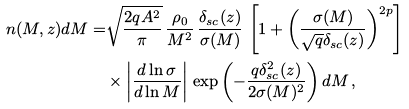Convert formula to latex. <formula><loc_0><loc_0><loc_500><loc_500>n ( M , z ) d M = & \sqrt { \frac { 2 q A ^ { 2 } } { \pi } } \, \frac { \rho _ { 0 } } { M ^ { 2 } } \, \frac { \delta _ { s c } ( z ) } { \sigma ( M ) } \, \left [ 1 + \left ( \frac { \sigma ( M ) } { \sqrt { q } \delta _ { s c } ( z ) } \right ) ^ { 2 p } \right ] \\ & \times \left | \frac { { d } \ln \sigma } { { d } \ln M } \right | \, \exp \left ( - \frac { q \delta _ { s c } ^ { 2 } ( z ) } { 2 \sigma ( M ) ^ { 2 } } \right ) d M \, ,</formula> 